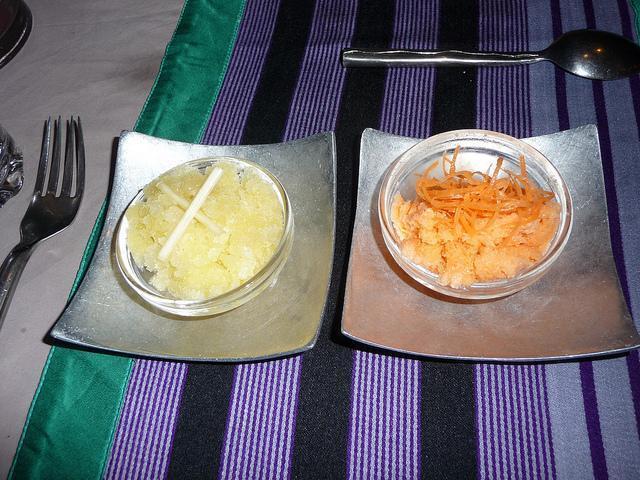How many plates are there?
Give a very brief answer. 2. How many bowls can you see?
Give a very brief answer. 2. 